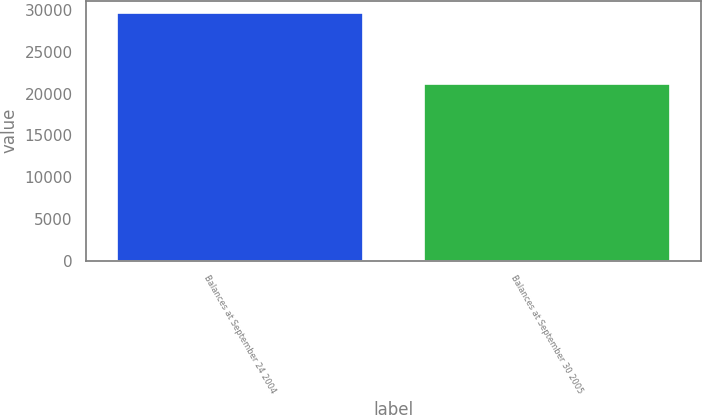Convert chart to OTSL. <chart><loc_0><loc_0><loc_500><loc_500><bar_chart><fcel>Balances at September 24 2004<fcel>Balances at September 30 2005<nl><fcel>29630<fcel>21204<nl></chart> 